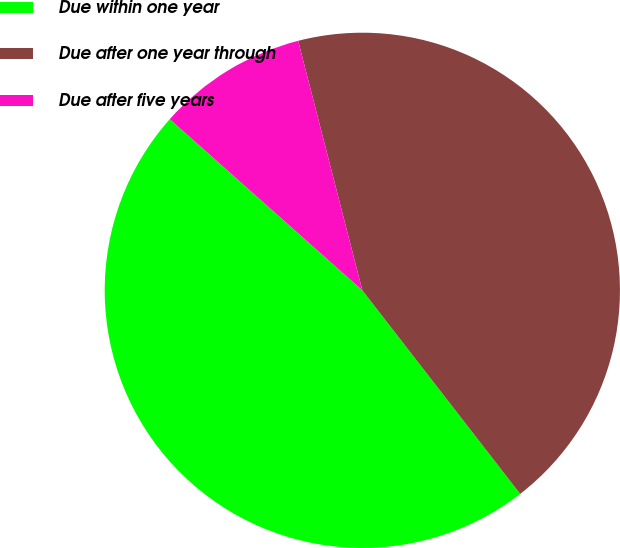Convert chart to OTSL. <chart><loc_0><loc_0><loc_500><loc_500><pie_chart><fcel>Due within one year<fcel>Due after one year through<fcel>Due after five years<nl><fcel>47.06%<fcel>43.51%<fcel>9.43%<nl></chart> 